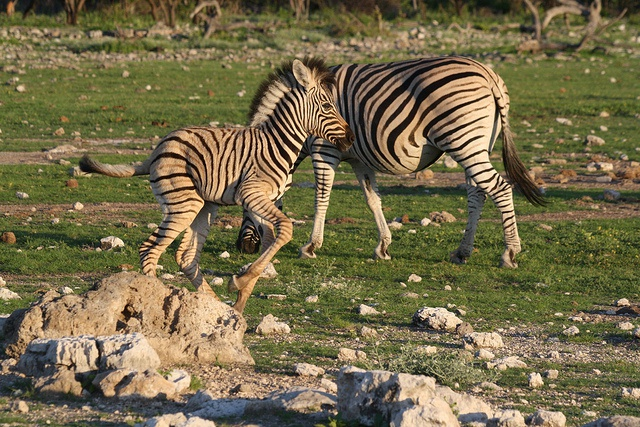Describe the objects in this image and their specific colors. I can see zebra in black, tan, and gray tones and zebra in black, tan, and gray tones in this image. 